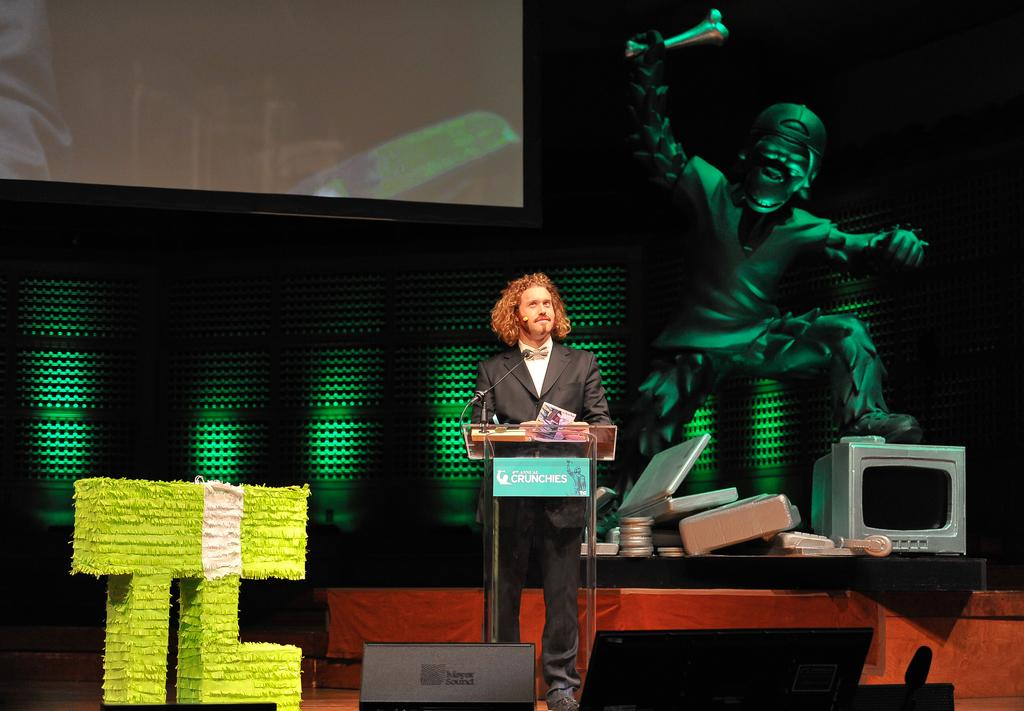<image>
Relay a brief, clear account of the picture shown. TJ Miller is on stage behind a podium reading "Crunchies". 